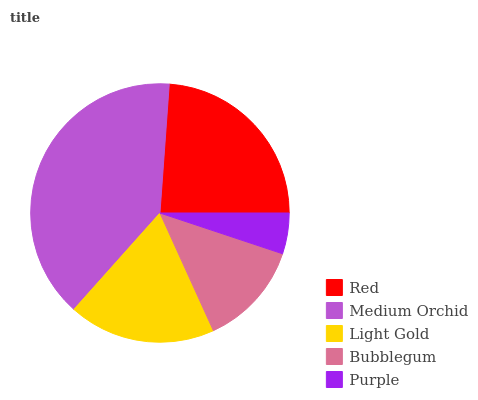Is Purple the minimum?
Answer yes or no. Yes. Is Medium Orchid the maximum?
Answer yes or no. Yes. Is Light Gold the minimum?
Answer yes or no. No. Is Light Gold the maximum?
Answer yes or no. No. Is Medium Orchid greater than Light Gold?
Answer yes or no. Yes. Is Light Gold less than Medium Orchid?
Answer yes or no. Yes. Is Light Gold greater than Medium Orchid?
Answer yes or no. No. Is Medium Orchid less than Light Gold?
Answer yes or no. No. Is Light Gold the high median?
Answer yes or no. Yes. Is Light Gold the low median?
Answer yes or no. Yes. Is Medium Orchid the high median?
Answer yes or no. No. Is Medium Orchid the low median?
Answer yes or no. No. 